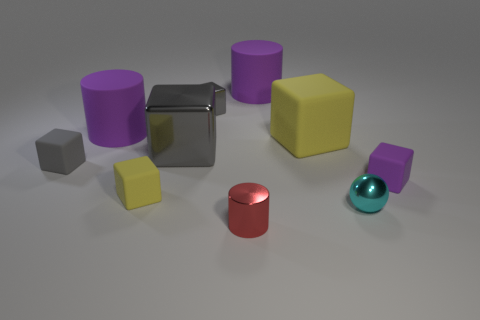How many gray cubes must be subtracted to get 1 gray cubes? 2 Subtract all red cylinders. How many gray blocks are left? 3 Subtract all tiny gray matte cubes. How many cubes are left? 5 Subtract all purple blocks. How many blocks are left? 5 Subtract 3 cubes. How many cubes are left? 3 Subtract all red cubes. Subtract all red balls. How many cubes are left? 6 Subtract all cylinders. How many objects are left? 7 Subtract 0 red blocks. How many objects are left? 10 Subtract all tiny purple rubber objects. Subtract all tiny cyan metal objects. How many objects are left? 8 Add 8 large cylinders. How many large cylinders are left? 10 